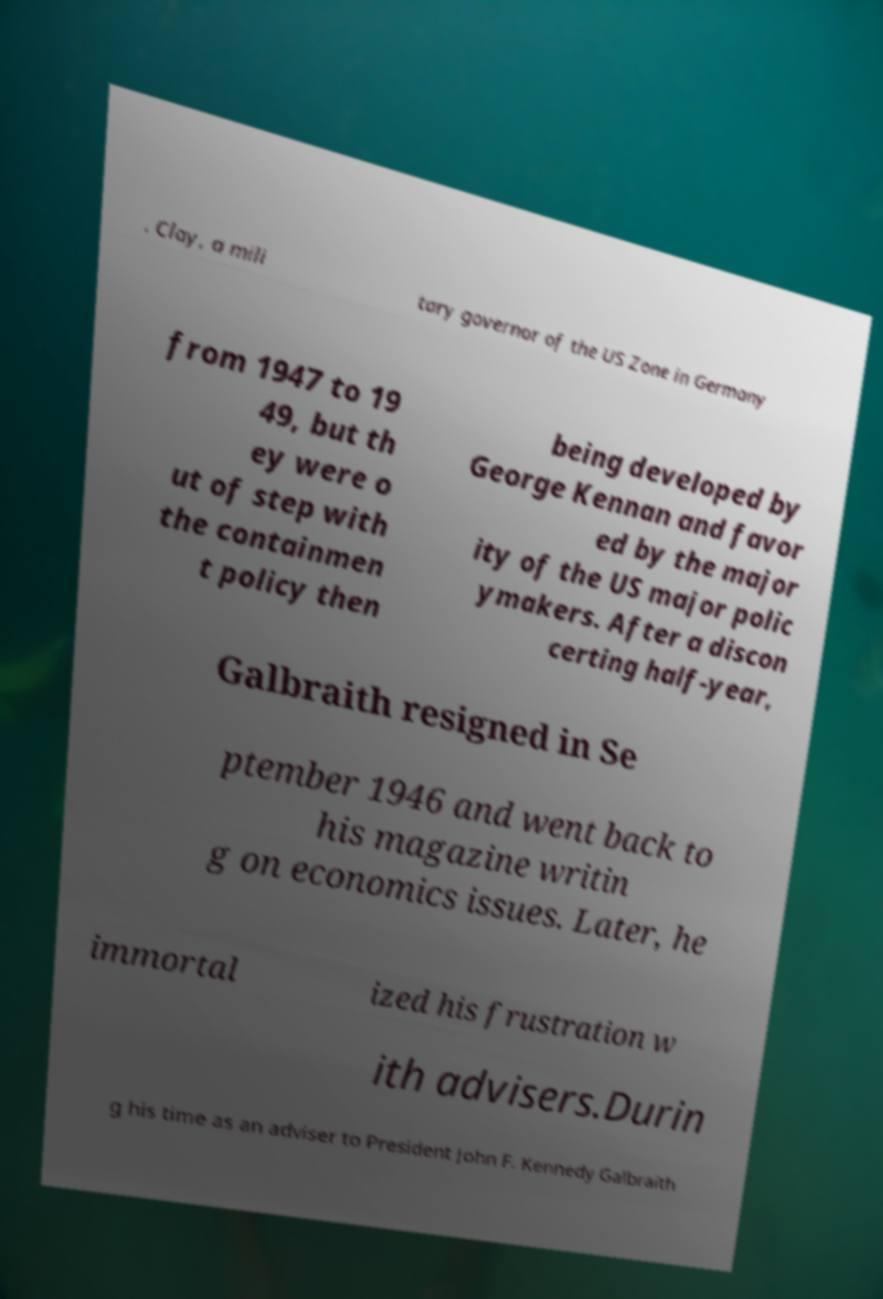There's text embedded in this image that I need extracted. Can you transcribe it verbatim? . Clay, a mili tary governor of the US Zone in Germany from 1947 to 19 49, but th ey were o ut of step with the containmen t policy then being developed by George Kennan and favor ed by the major ity of the US major polic ymakers. After a discon certing half-year, Galbraith resigned in Se ptember 1946 and went back to his magazine writin g on economics issues. Later, he immortal ized his frustration w ith advisers.Durin g his time as an adviser to President John F. Kennedy Galbraith 